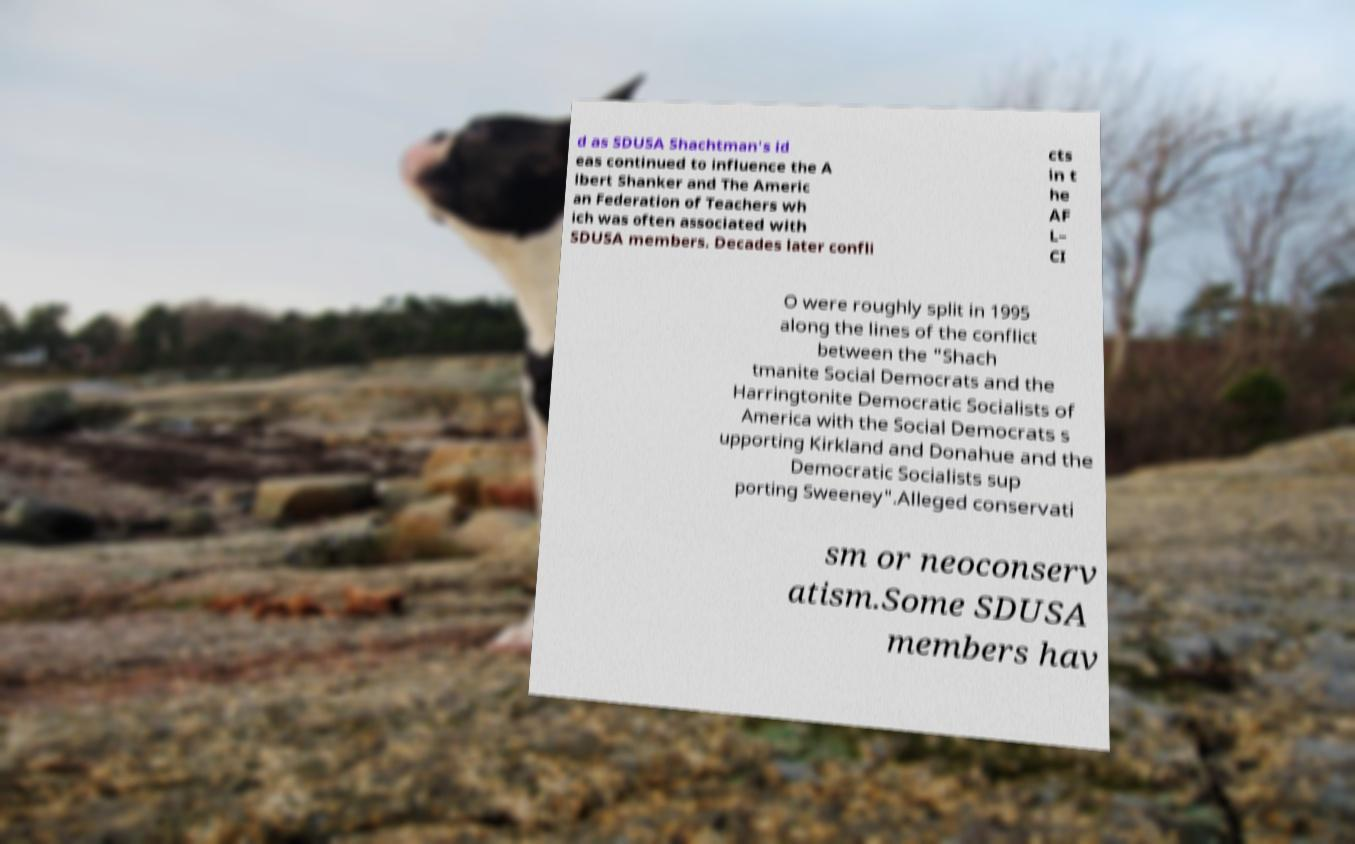I need the written content from this picture converted into text. Can you do that? d as SDUSA Shachtman's id eas continued to influence the A lbert Shanker and The Americ an Federation of Teachers wh ich was often associated with SDUSA members. Decades later confli cts in t he AF L– CI O were roughly split in 1995 along the lines of the conflict between the "Shach tmanite Social Democrats and the Harringtonite Democratic Socialists of America with the Social Democrats s upporting Kirkland and Donahue and the Democratic Socialists sup porting Sweeney".Alleged conservati sm or neoconserv atism.Some SDUSA members hav 